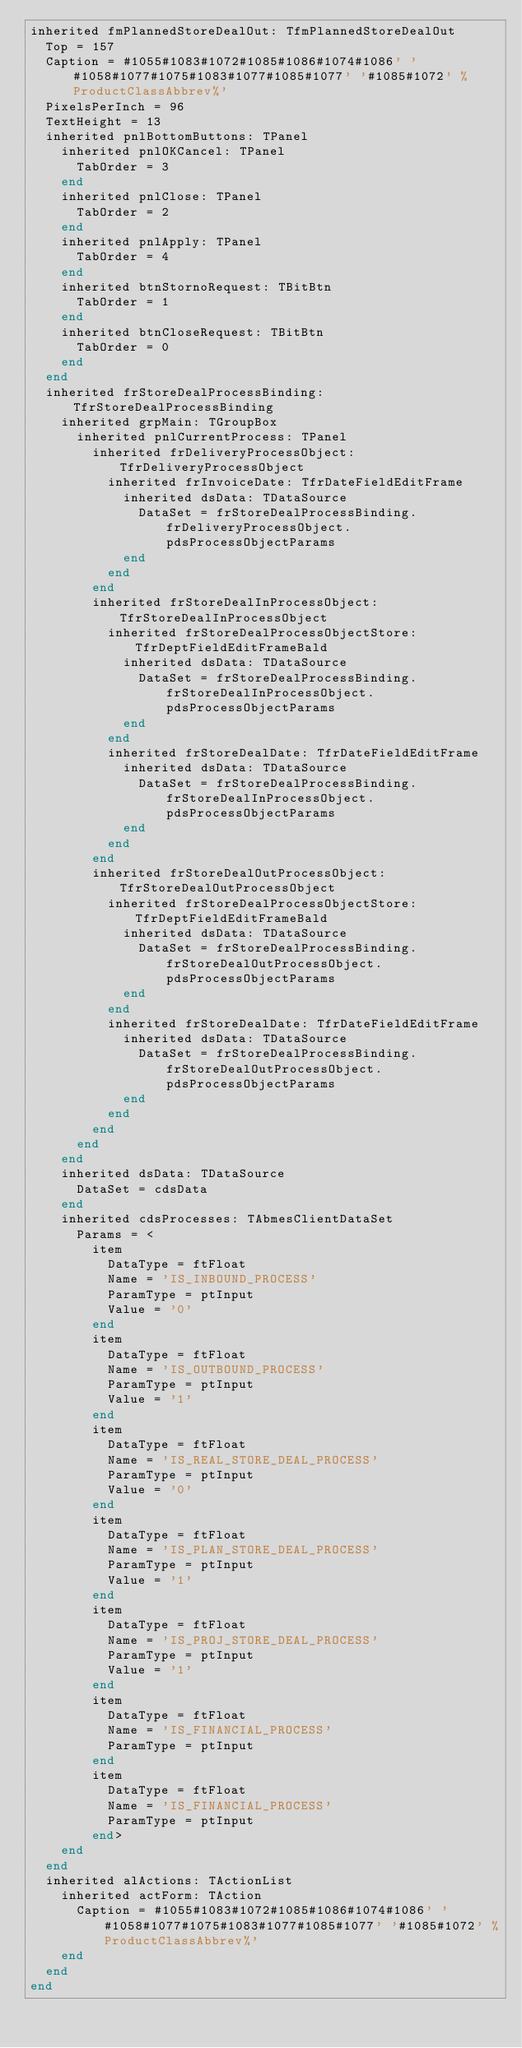Convert code to text. <code><loc_0><loc_0><loc_500><loc_500><_Pascal_>inherited fmPlannedStoreDealOut: TfmPlannedStoreDealOut
  Top = 157
  Caption = #1055#1083#1072#1085#1086#1074#1086' '#1058#1077#1075#1083#1077#1085#1077' '#1085#1072' %ProductClassAbbrev%'
  PixelsPerInch = 96
  TextHeight = 13
  inherited pnlBottomButtons: TPanel
    inherited pnlOKCancel: TPanel
      TabOrder = 3
    end
    inherited pnlClose: TPanel
      TabOrder = 2
    end
    inherited pnlApply: TPanel
      TabOrder = 4
    end
    inherited btnStornoRequest: TBitBtn
      TabOrder = 1
    end
    inherited btnCloseRequest: TBitBtn
      TabOrder = 0
    end
  end
  inherited frStoreDealProcessBinding: TfrStoreDealProcessBinding
    inherited grpMain: TGroupBox
      inherited pnlCurrentProcess: TPanel
        inherited frDeliveryProcessObject: TfrDeliveryProcessObject
          inherited frInvoiceDate: TfrDateFieldEditFrame
            inherited dsData: TDataSource
              DataSet = frStoreDealProcessBinding.frDeliveryProcessObject.pdsProcessObjectParams
            end
          end
        end
        inherited frStoreDealInProcessObject: TfrStoreDealInProcessObject
          inherited frStoreDealProcessObjectStore: TfrDeptFieldEditFrameBald
            inherited dsData: TDataSource
              DataSet = frStoreDealProcessBinding.frStoreDealInProcessObject.pdsProcessObjectParams
            end
          end
          inherited frStoreDealDate: TfrDateFieldEditFrame
            inherited dsData: TDataSource
              DataSet = frStoreDealProcessBinding.frStoreDealInProcessObject.pdsProcessObjectParams
            end
          end
        end
        inherited frStoreDealOutProcessObject: TfrStoreDealOutProcessObject
          inherited frStoreDealProcessObjectStore: TfrDeptFieldEditFrameBald
            inherited dsData: TDataSource
              DataSet = frStoreDealProcessBinding.frStoreDealOutProcessObject.pdsProcessObjectParams
            end
          end
          inherited frStoreDealDate: TfrDateFieldEditFrame
            inherited dsData: TDataSource
              DataSet = frStoreDealProcessBinding.frStoreDealOutProcessObject.pdsProcessObjectParams
            end
          end
        end
      end
    end
    inherited dsData: TDataSource
      DataSet = cdsData
    end
    inherited cdsProcesses: TAbmesClientDataSet
      Params = <
        item
          DataType = ftFloat
          Name = 'IS_INBOUND_PROCESS'
          ParamType = ptInput
          Value = '0'
        end
        item
          DataType = ftFloat
          Name = 'IS_OUTBOUND_PROCESS'
          ParamType = ptInput
          Value = '1'
        end
        item
          DataType = ftFloat
          Name = 'IS_REAL_STORE_DEAL_PROCESS'
          ParamType = ptInput
          Value = '0'
        end
        item
          DataType = ftFloat
          Name = 'IS_PLAN_STORE_DEAL_PROCESS'
          ParamType = ptInput
          Value = '1'
        end
        item
          DataType = ftFloat
          Name = 'IS_PROJ_STORE_DEAL_PROCESS'
          ParamType = ptInput
          Value = '1'
        end
        item
          DataType = ftFloat
          Name = 'IS_FINANCIAL_PROCESS'
          ParamType = ptInput
        end
        item
          DataType = ftFloat
          Name = 'IS_FINANCIAL_PROCESS'
          ParamType = ptInput
        end>
    end
  end
  inherited alActions: TActionList
    inherited actForm: TAction
      Caption = #1055#1083#1072#1085#1086#1074#1086' '#1058#1077#1075#1083#1077#1085#1077' '#1085#1072' %ProductClassAbbrev%'
    end
  end
end
</code> 